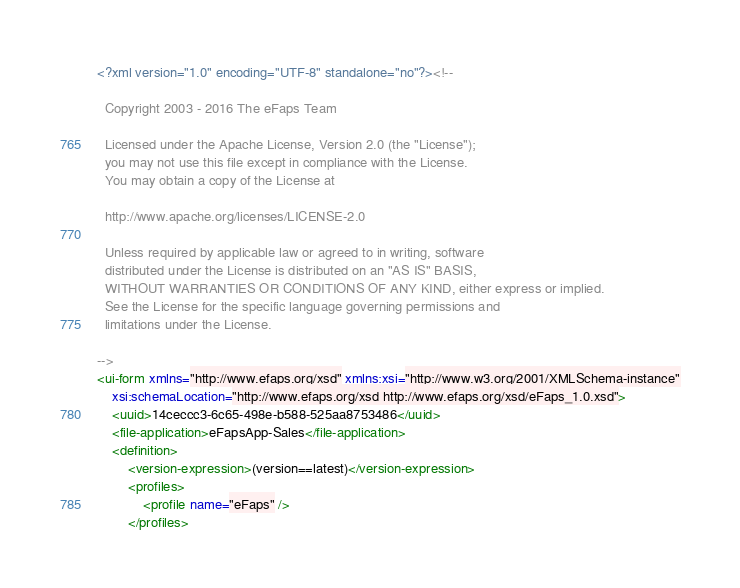Convert code to text. <code><loc_0><loc_0><loc_500><loc_500><_XML_><?xml version="1.0" encoding="UTF-8" standalone="no"?><!--

  Copyright 2003 - 2016 The eFaps Team

  Licensed under the Apache License, Version 2.0 (the "License");
  you may not use this file except in compliance with the License.
  You may obtain a copy of the License at

  http://www.apache.org/licenses/LICENSE-2.0

  Unless required by applicable law or agreed to in writing, software
  distributed under the License is distributed on an "AS IS" BASIS,
  WITHOUT WARRANTIES OR CONDITIONS OF ANY KIND, either express or implied.
  See the License for the specific language governing permissions and
  limitations under the License.

-->
<ui-form xmlns="http://www.efaps.org/xsd" xmlns:xsi="http://www.w3.org/2001/XMLSchema-instance"
    xsi:schemaLocation="http://www.efaps.org/xsd http://www.efaps.org/xsd/eFaps_1.0.xsd">
    <uuid>14ceccc3-6c65-498e-b588-525aa8753486</uuid>
    <file-application>eFapsApp-Sales</file-application>
    <definition>
        <version-expression>(version==latest)</version-expression>
        <profiles>
            <profile name="eFaps" />
        </profiles></code> 